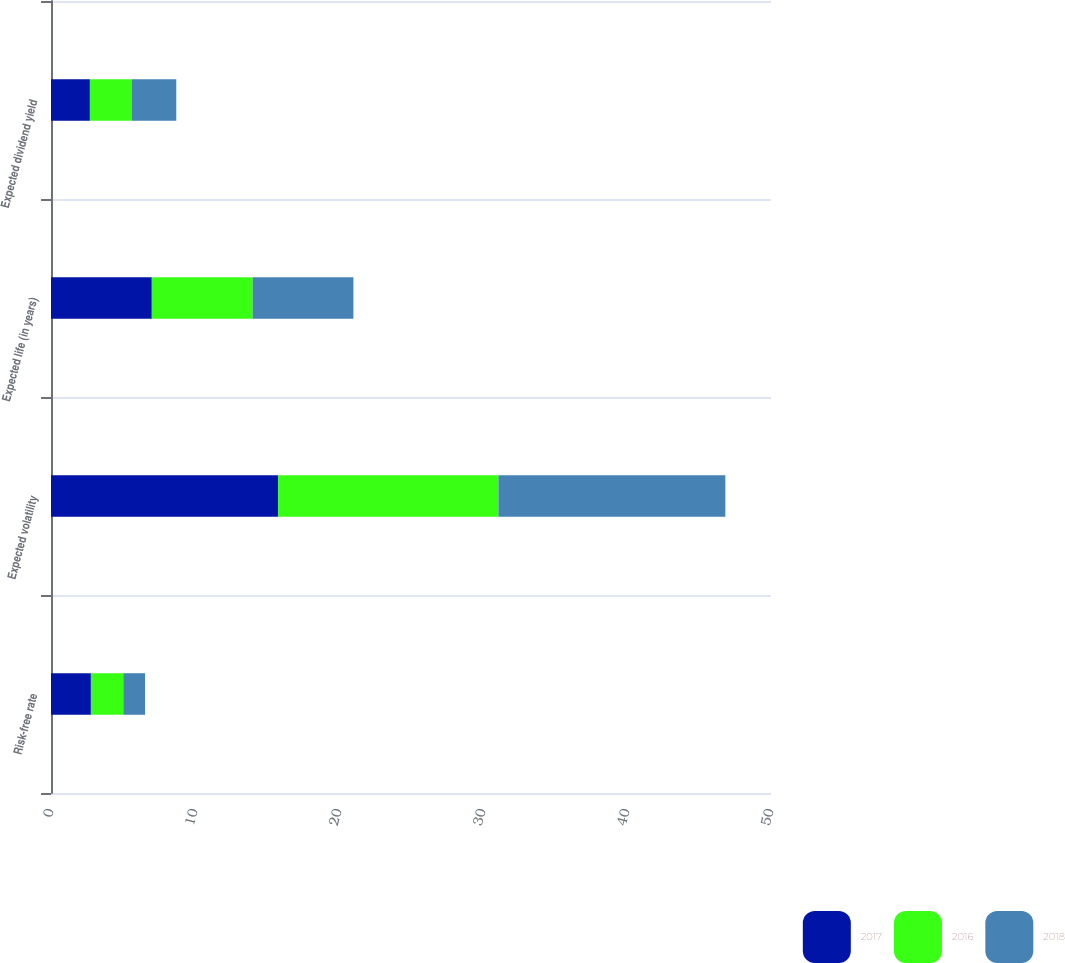Convert chart to OTSL. <chart><loc_0><loc_0><loc_500><loc_500><stacked_bar_chart><ecel><fcel>Risk-free rate<fcel>Expected volatility<fcel>Expected life (in years)<fcel>Expected dividend yield<nl><fcel>2017<fcel>2.77<fcel>15.77<fcel>7<fcel>2.7<nl><fcel>2016<fcel>2.25<fcel>15.3<fcel>7<fcel>2.9<nl><fcel>2018<fcel>1.51<fcel>15.76<fcel>7<fcel>3.1<nl></chart> 